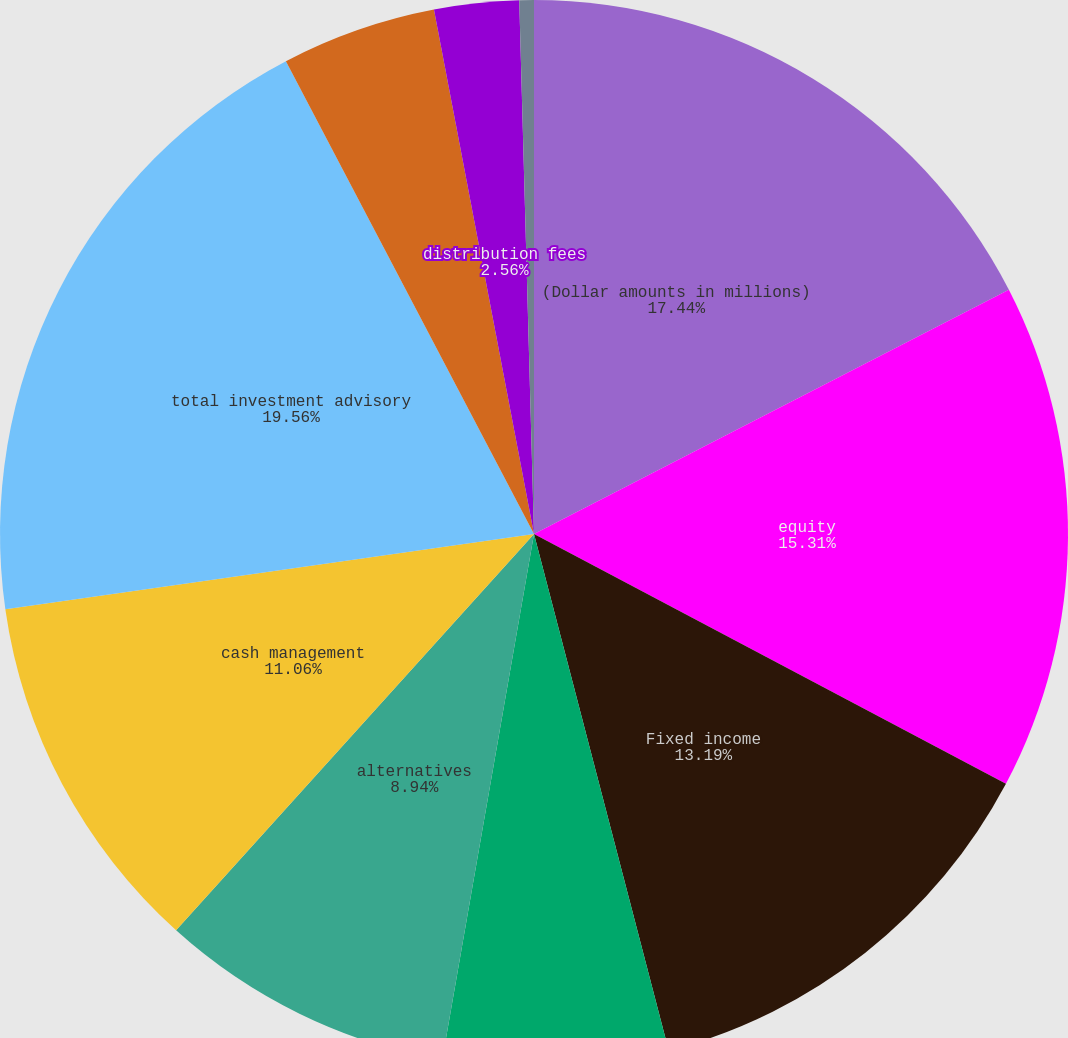Convert chart. <chart><loc_0><loc_0><loc_500><loc_500><pie_chart><fcel>(Dollar amounts in millions)<fcel>equity<fcel>Fixed income<fcel>Multi-asset class<fcel>alternatives<fcel>cash management<fcel>total investment advisory<fcel>BlackRock Solutions and<fcel>distribution fees<fcel>Other revenue<nl><fcel>17.44%<fcel>15.31%<fcel>13.19%<fcel>6.81%<fcel>8.94%<fcel>11.06%<fcel>19.56%<fcel>4.69%<fcel>2.56%<fcel>0.44%<nl></chart> 